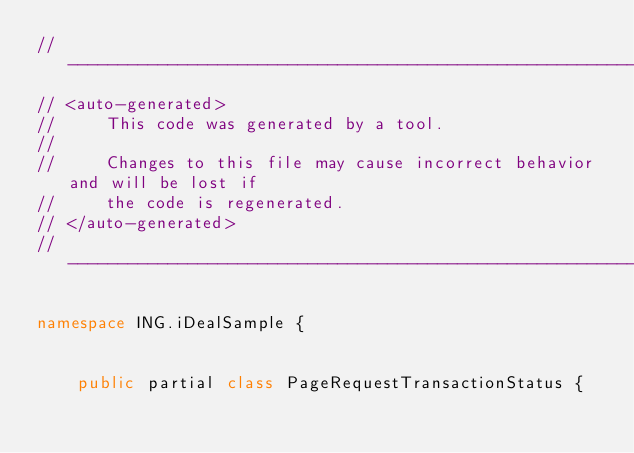<code> <loc_0><loc_0><loc_500><loc_500><_C#_>//------------------------------------------------------------------------------
// <auto-generated>
//     This code was generated by a tool.
//
//     Changes to this file may cause incorrect behavior and will be lost if
//     the code is regenerated. 
// </auto-generated>
//------------------------------------------------------------------------------

namespace ING.iDealSample {
    
    
    public partial class PageRequestTransactionStatus {</code> 